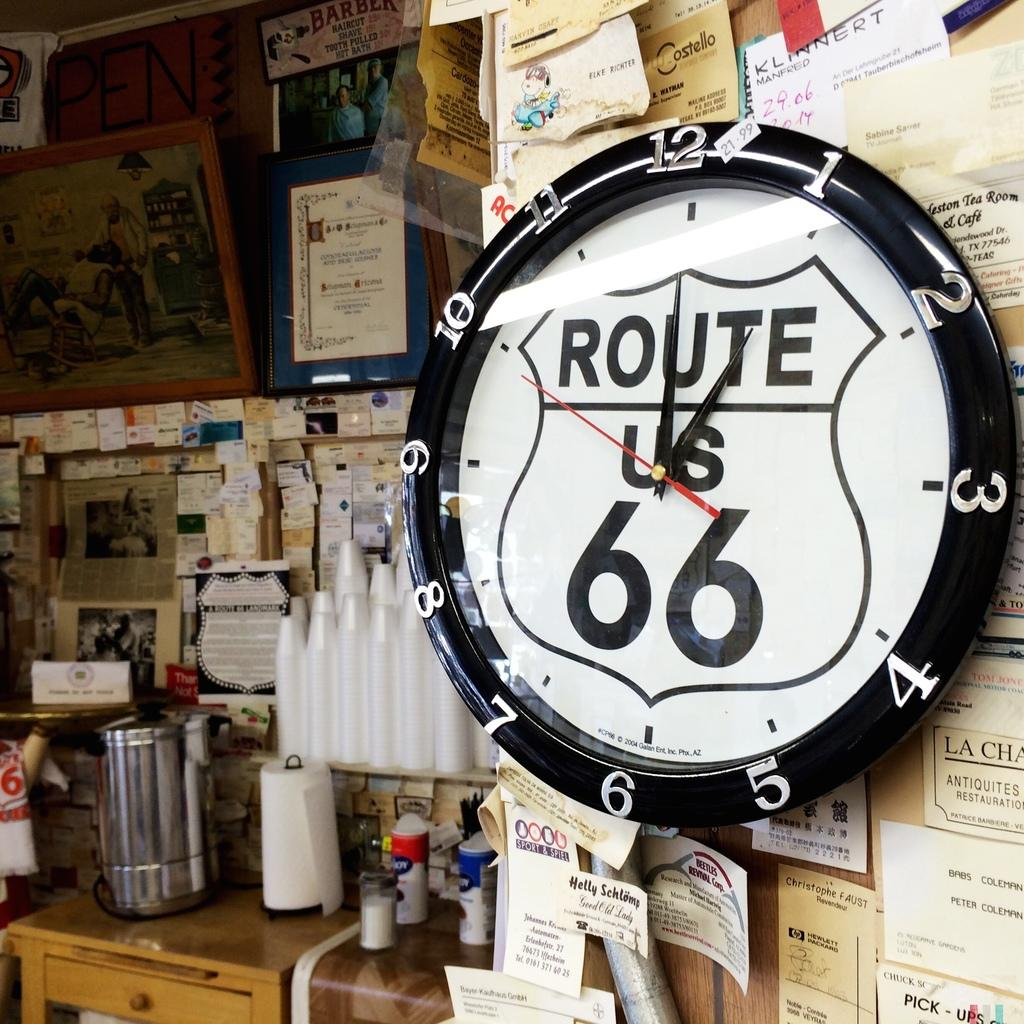Provide a one-sentence caption for the provided image. the route 66 that is on a clock. 